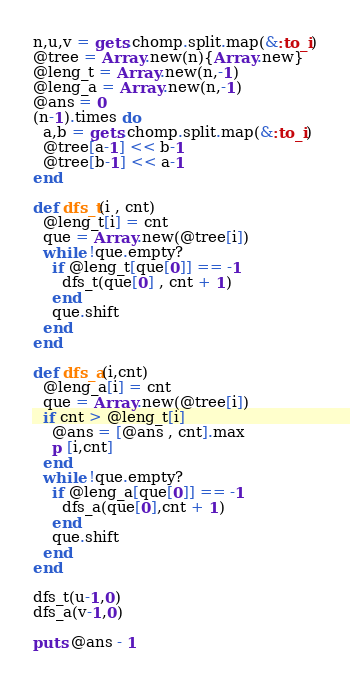<code> <loc_0><loc_0><loc_500><loc_500><_Ruby_>n,u,v = gets.chomp.split.map(&:to_i)
@tree = Array.new(n){Array.new}
@leng_t = Array.new(n,-1)
@leng_a = Array.new(n,-1)
@ans = 0
(n-1).times do
  a,b = gets.chomp.split.map(&:to_i)
  @tree[a-1] << b-1
  @tree[b-1] << a-1
end

def dfs_t(i , cnt)
  @leng_t[i] = cnt
  que = Array.new(@tree[i])
  while !que.empty?
    if @leng_t[que[0]] == -1
      dfs_t(que[0] , cnt + 1)
    end
    que.shift
  end
end

def dfs_a(i,cnt)
  @leng_a[i] = cnt
  que = Array.new(@tree[i])
  if cnt > @leng_t[i]
    @ans = [@ans , cnt].max
    p [i,cnt]
  end
  while !que.empty?
    if @leng_a[que[0]] == -1
      dfs_a(que[0],cnt + 1)
    end
    que.shift
  end
end

dfs_t(u-1,0)
dfs_a(v-1,0)

puts @ans - 1</code> 